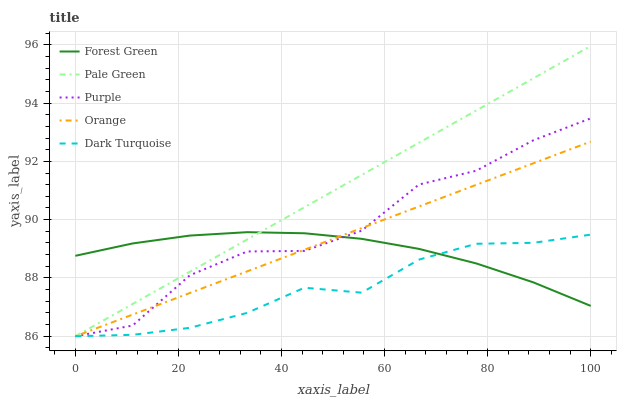Does Dark Turquoise have the minimum area under the curve?
Answer yes or no. Yes. Does Pale Green have the maximum area under the curve?
Answer yes or no. Yes. Does Orange have the minimum area under the curve?
Answer yes or no. No. Does Orange have the maximum area under the curve?
Answer yes or no. No. Is Pale Green the smoothest?
Answer yes or no. Yes. Is Purple the roughest?
Answer yes or no. Yes. Is Orange the smoothest?
Answer yes or no. No. Is Orange the roughest?
Answer yes or no. No. Does Purple have the lowest value?
Answer yes or no. Yes. Does Forest Green have the lowest value?
Answer yes or no. No. Does Pale Green have the highest value?
Answer yes or no. Yes. Does Orange have the highest value?
Answer yes or no. No. Does Dark Turquoise intersect Orange?
Answer yes or no. Yes. Is Dark Turquoise less than Orange?
Answer yes or no. No. Is Dark Turquoise greater than Orange?
Answer yes or no. No. 